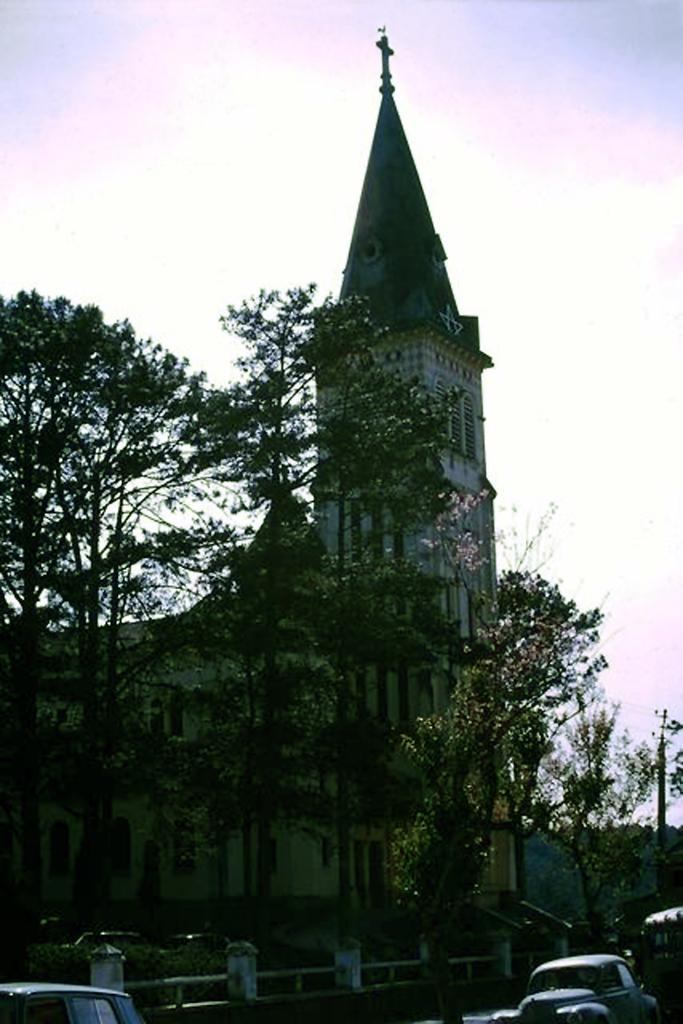What type of vegetation is in front of the building in the image? There are trees in front of the building in the image. What type of vehicle can be seen in the bottom right of the image? There is a car in the bottom right of the image. What is visible in the background of the image? There is a sky visible in the background of the image. What type of system is being used to coach the trees in the image? There is no system or coaching involved with the trees in the image; they are simply standing in front of the building. What type of earth is visible in the image? The image does not show any specific type of earth; it only shows trees, a building, a car, and the sky. 